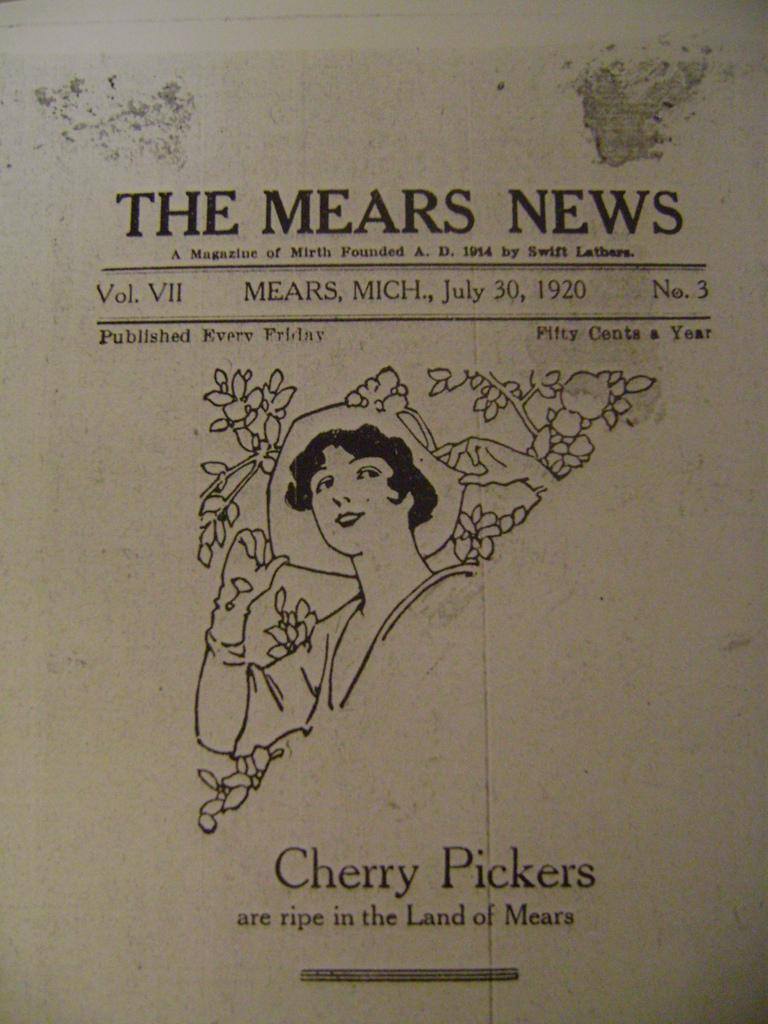What is located in the center of the image? There is a paper and a lady in the center of the image. What can be seen at the top and bottom of the image? There is text at the top and bottom of the image. What type of boot is the lady wearing in the image? There is no mention of a boot or any footwear in the image, so it cannot be determined from the image. 